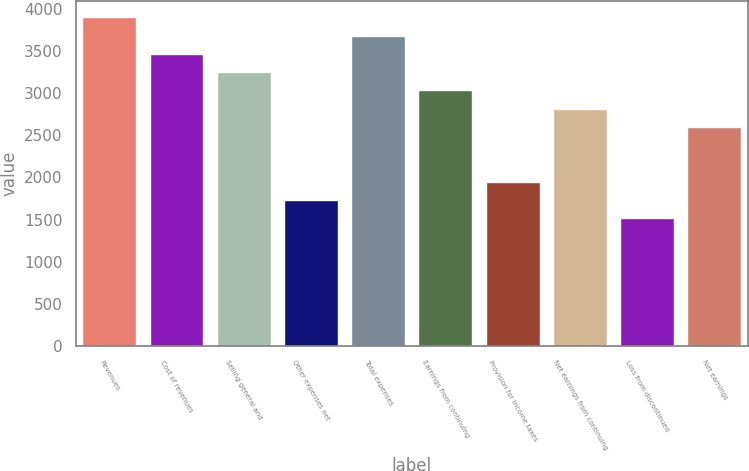Convert chart. <chart><loc_0><loc_0><loc_500><loc_500><bar_chart><fcel>Revenues<fcel>Cost of revenues<fcel>Selling general and<fcel>Other expenses net<fcel>Total expenses<fcel>Earnings from continuing<fcel>Provision for income taxes<fcel>Net earnings from continuing<fcel>Loss from discontinued<fcel>Net earnings<nl><fcel>3900.44<fcel>3467.06<fcel>3250.37<fcel>1733.54<fcel>3683.75<fcel>3033.68<fcel>1950.23<fcel>2816.99<fcel>1516.85<fcel>2600.3<nl></chart> 